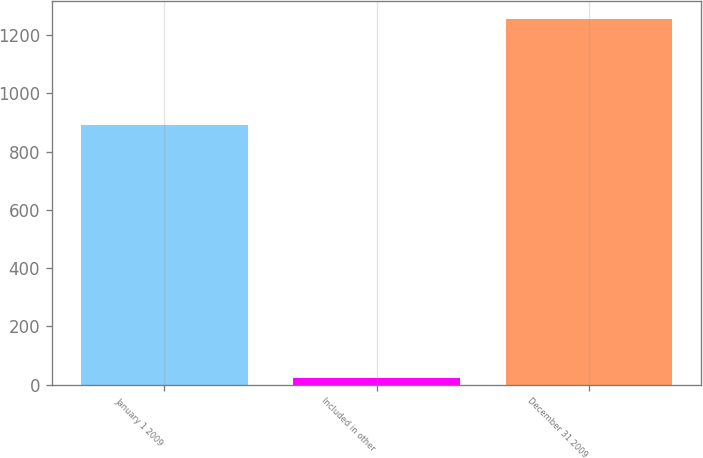<chart> <loc_0><loc_0><loc_500><loc_500><bar_chart><fcel>January 1 2009<fcel>Included in other<fcel>December 31 2009<nl><fcel>892<fcel>22<fcel>1254<nl></chart> 